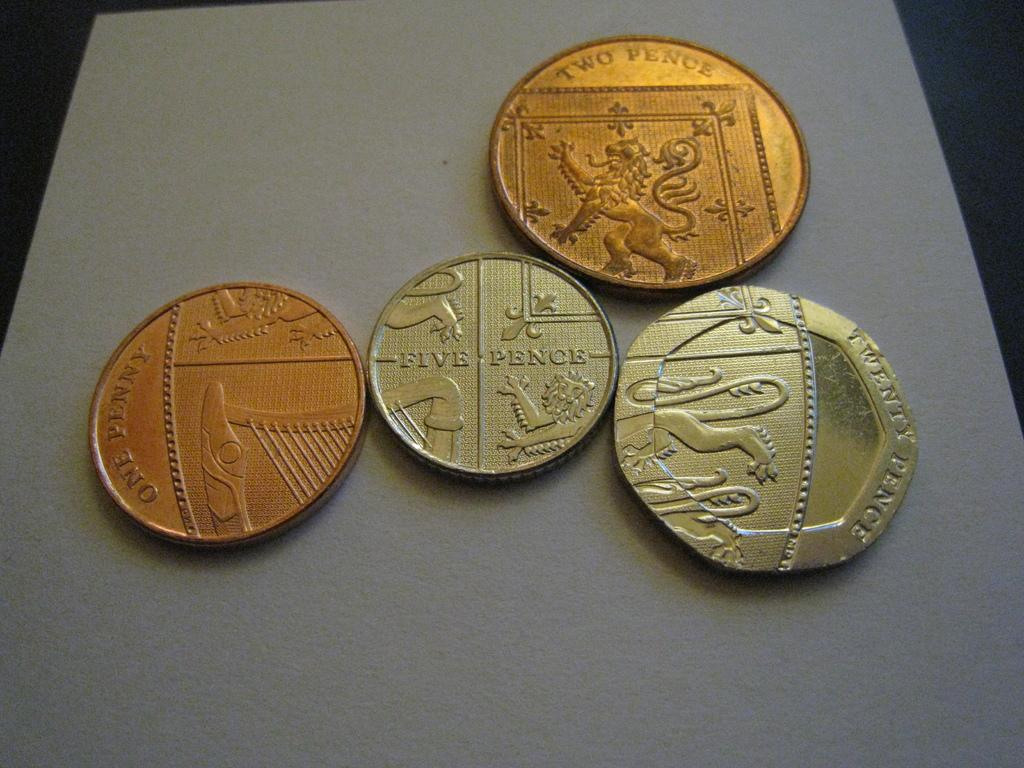<image>
Share a concise interpretation of the image provided. Several coins of different denominations sit on top of a table, one reading two pence with a dragon engraved on its sid 